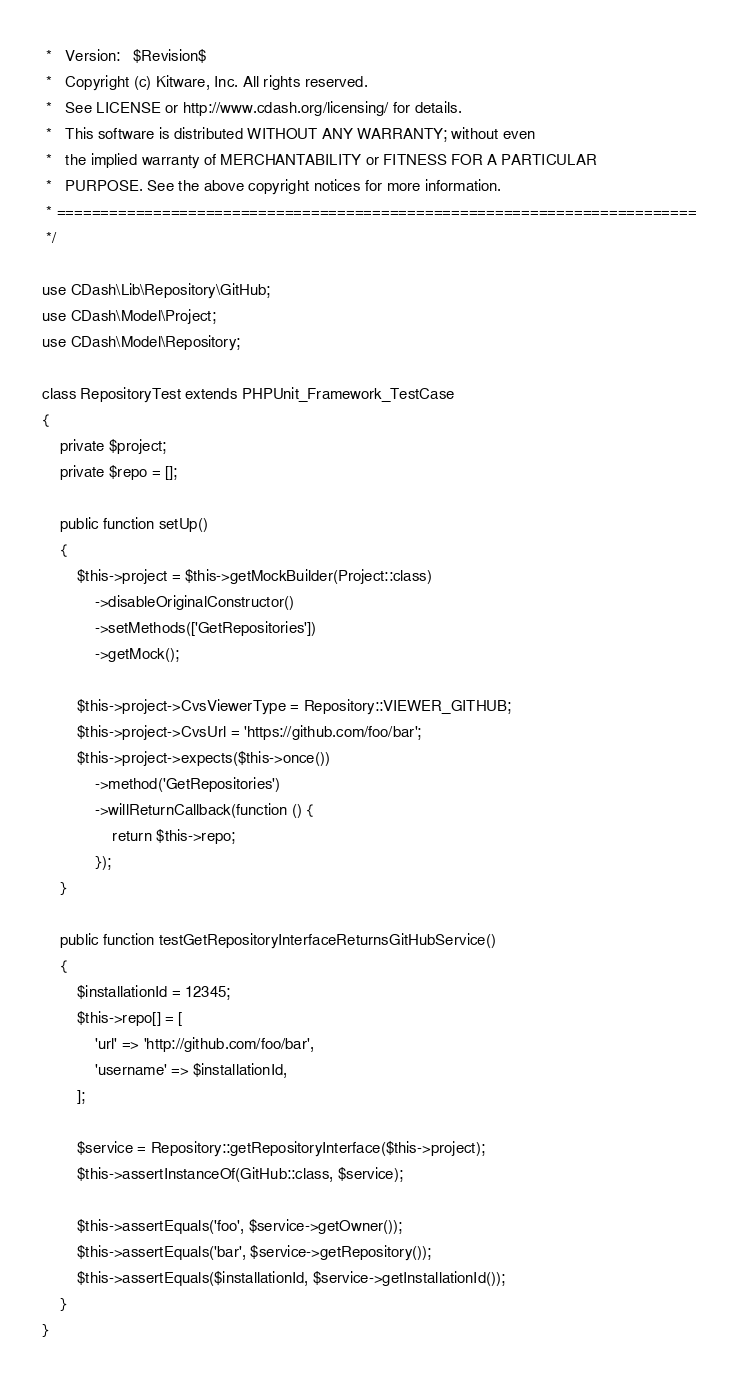<code> <loc_0><loc_0><loc_500><loc_500><_PHP_> *   Version:   $Revision$
 *   Copyright (c) Kitware, Inc. All rights reserved.
 *   See LICENSE or http://www.cdash.org/licensing/ for details.
 *   This software is distributed WITHOUT ANY WARRANTY; without even
 *   the implied warranty of MERCHANTABILITY or FITNESS FOR A PARTICULAR
 *   PURPOSE. See the above copyright notices for more information.
 * =========================================================================
 */

use CDash\Lib\Repository\GitHub;
use CDash\Model\Project;
use CDash\Model\Repository;

class RepositoryTest extends PHPUnit_Framework_TestCase
{
    private $project;
    private $repo = [];

    public function setUp()
    {
        $this->project = $this->getMockBuilder(Project::class)
            ->disableOriginalConstructor()
            ->setMethods(['GetRepositories'])
            ->getMock();

        $this->project->CvsViewerType = Repository::VIEWER_GITHUB;
        $this->project->CvsUrl = 'https://github.com/foo/bar';
        $this->project->expects($this->once())
            ->method('GetRepositories')
            ->willReturnCallback(function () {
                return $this->repo;
            });
    }

    public function testGetRepositoryInterfaceReturnsGitHubService()
    {
        $installationId = 12345;
        $this->repo[] = [
            'url' => 'http://github.com/foo/bar',
            'username' => $installationId,
        ];

        $service = Repository::getRepositoryInterface($this->project);
        $this->assertInstanceOf(GitHub::class, $service);

        $this->assertEquals('foo', $service->getOwner());
        $this->assertEquals('bar', $service->getRepository());
        $this->assertEquals($installationId, $service->getInstallationId());
    }
}
</code> 